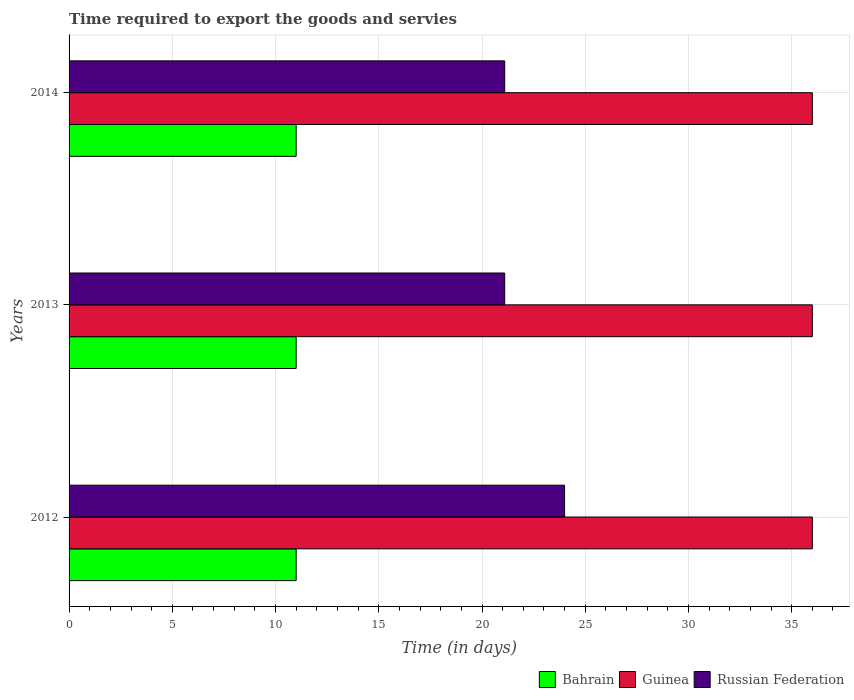Are the number of bars per tick equal to the number of legend labels?
Make the answer very short. Yes. Are the number of bars on each tick of the Y-axis equal?
Make the answer very short. Yes. What is the number of days required to export the goods and services in Bahrain in 2012?
Your response must be concise. 11. Across all years, what is the maximum number of days required to export the goods and services in Russian Federation?
Give a very brief answer. 24. Across all years, what is the minimum number of days required to export the goods and services in Russian Federation?
Your answer should be very brief. 21.1. In which year was the number of days required to export the goods and services in Russian Federation maximum?
Give a very brief answer. 2012. What is the total number of days required to export the goods and services in Russian Federation in the graph?
Give a very brief answer. 66.2. What is the difference between the number of days required to export the goods and services in Russian Federation in 2014 and the number of days required to export the goods and services in Bahrain in 2012?
Provide a short and direct response. 10.1. What is the average number of days required to export the goods and services in Russian Federation per year?
Keep it short and to the point. 22.07. What is the ratio of the number of days required to export the goods and services in Bahrain in 2012 to that in 2013?
Your answer should be very brief. 1. Is the number of days required to export the goods and services in Guinea in 2012 less than that in 2014?
Ensure brevity in your answer.  No. Is the difference between the number of days required to export the goods and services in Bahrain in 2012 and 2014 greater than the difference between the number of days required to export the goods and services in Russian Federation in 2012 and 2014?
Your answer should be very brief. No. What is the difference between the highest and the second highest number of days required to export the goods and services in Russian Federation?
Your answer should be very brief. 2.9. What does the 3rd bar from the top in 2013 represents?
Your answer should be very brief. Bahrain. What does the 3rd bar from the bottom in 2013 represents?
Provide a succinct answer. Russian Federation. Is it the case that in every year, the sum of the number of days required to export the goods and services in Russian Federation and number of days required to export the goods and services in Guinea is greater than the number of days required to export the goods and services in Bahrain?
Your response must be concise. Yes. Are all the bars in the graph horizontal?
Make the answer very short. Yes. What is the difference between two consecutive major ticks on the X-axis?
Offer a terse response. 5. Does the graph contain any zero values?
Your answer should be compact. No. How are the legend labels stacked?
Give a very brief answer. Horizontal. What is the title of the graph?
Ensure brevity in your answer.  Time required to export the goods and servies. Does "Middle East & North Africa (developing only)" appear as one of the legend labels in the graph?
Your answer should be very brief. No. What is the label or title of the X-axis?
Your response must be concise. Time (in days). What is the label or title of the Y-axis?
Ensure brevity in your answer.  Years. What is the Time (in days) of Guinea in 2012?
Offer a very short reply. 36. What is the Time (in days) in Russian Federation in 2012?
Provide a succinct answer. 24. What is the Time (in days) of Guinea in 2013?
Offer a very short reply. 36. What is the Time (in days) in Russian Federation in 2013?
Provide a succinct answer. 21.1. What is the Time (in days) of Guinea in 2014?
Ensure brevity in your answer.  36. What is the Time (in days) of Russian Federation in 2014?
Ensure brevity in your answer.  21.1. Across all years, what is the maximum Time (in days) in Bahrain?
Offer a very short reply. 11. Across all years, what is the maximum Time (in days) in Russian Federation?
Offer a terse response. 24. Across all years, what is the minimum Time (in days) in Russian Federation?
Ensure brevity in your answer.  21.1. What is the total Time (in days) in Bahrain in the graph?
Give a very brief answer. 33. What is the total Time (in days) of Guinea in the graph?
Ensure brevity in your answer.  108. What is the total Time (in days) in Russian Federation in the graph?
Keep it short and to the point. 66.2. What is the difference between the Time (in days) in Bahrain in 2012 and that in 2013?
Provide a succinct answer. 0. What is the difference between the Time (in days) of Guinea in 2012 and that in 2013?
Make the answer very short. 0. What is the difference between the Time (in days) in Russian Federation in 2012 and that in 2013?
Keep it short and to the point. 2.9. What is the difference between the Time (in days) of Bahrain in 2013 and that in 2014?
Your answer should be very brief. 0. What is the difference between the Time (in days) of Guinea in 2013 and that in 2014?
Offer a terse response. 0. What is the difference between the Time (in days) in Russian Federation in 2013 and that in 2014?
Your answer should be compact. 0. What is the difference between the Time (in days) in Guinea in 2012 and the Time (in days) in Russian Federation in 2013?
Your answer should be very brief. 14.9. What is the difference between the Time (in days) in Bahrain in 2012 and the Time (in days) in Guinea in 2014?
Your answer should be very brief. -25. What is the difference between the Time (in days) in Bahrain in 2012 and the Time (in days) in Russian Federation in 2014?
Your answer should be compact. -10.1. What is the average Time (in days) of Guinea per year?
Your response must be concise. 36. What is the average Time (in days) in Russian Federation per year?
Provide a short and direct response. 22.07. In the year 2012, what is the difference between the Time (in days) of Bahrain and Time (in days) of Guinea?
Make the answer very short. -25. In the year 2012, what is the difference between the Time (in days) of Guinea and Time (in days) of Russian Federation?
Ensure brevity in your answer.  12. In the year 2013, what is the difference between the Time (in days) in Guinea and Time (in days) in Russian Federation?
Your answer should be very brief. 14.9. In the year 2014, what is the difference between the Time (in days) in Bahrain and Time (in days) in Guinea?
Provide a succinct answer. -25. In the year 2014, what is the difference between the Time (in days) in Bahrain and Time (in days) in Russian Federation?
Make the answer very short. -10.1. In the year 2014, what is the difference between the Time (in days) in Guinea and Time (in days) in Russian Federation?
Make the answer very short. 14.9. What is the ratio of the Time (in days) in Russian Federation in 2012 to that in 2013?
Offer a terse response. 1.14. What is the ratio of the Time (in days) of Bahrain in 2012 to that in 2014?
Offer a terse response. 1. What is the ratio of the Time (in days) in Guinea in 2012 to that in 2014?
Your response must be concise. 1. What is the ratio of the Time (in days) of Russian Federation in 2012 to that in 2014?
Offer a very short reply. 1.14. What is the difference between the highest and the second highest Time (in days) of Bahrain?
Your answer should be very brief. 0. What is the difference between the highest and the second highest Time (in days) in Guinea?
Provide a short and direct response. 0. What is the difference between the highest and the lowest Time (in days) in Guinea?
Your response must be concise. 0. What is the difference between the highest and the lowest Time (in days) in Russian Federation?
Offer a terse response. 2.9. 